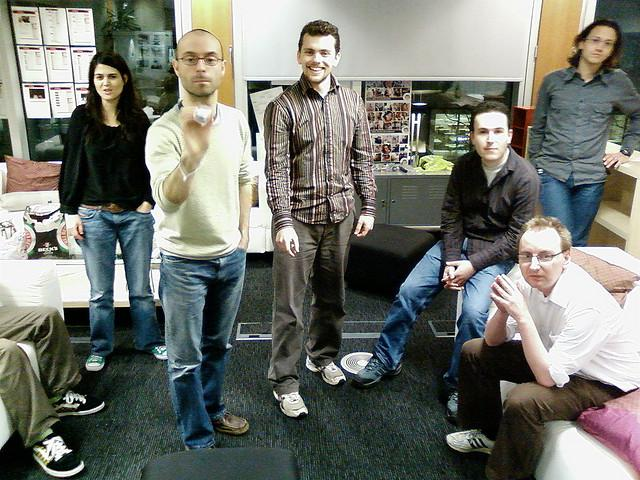Where is the group focusing their attention? screen 